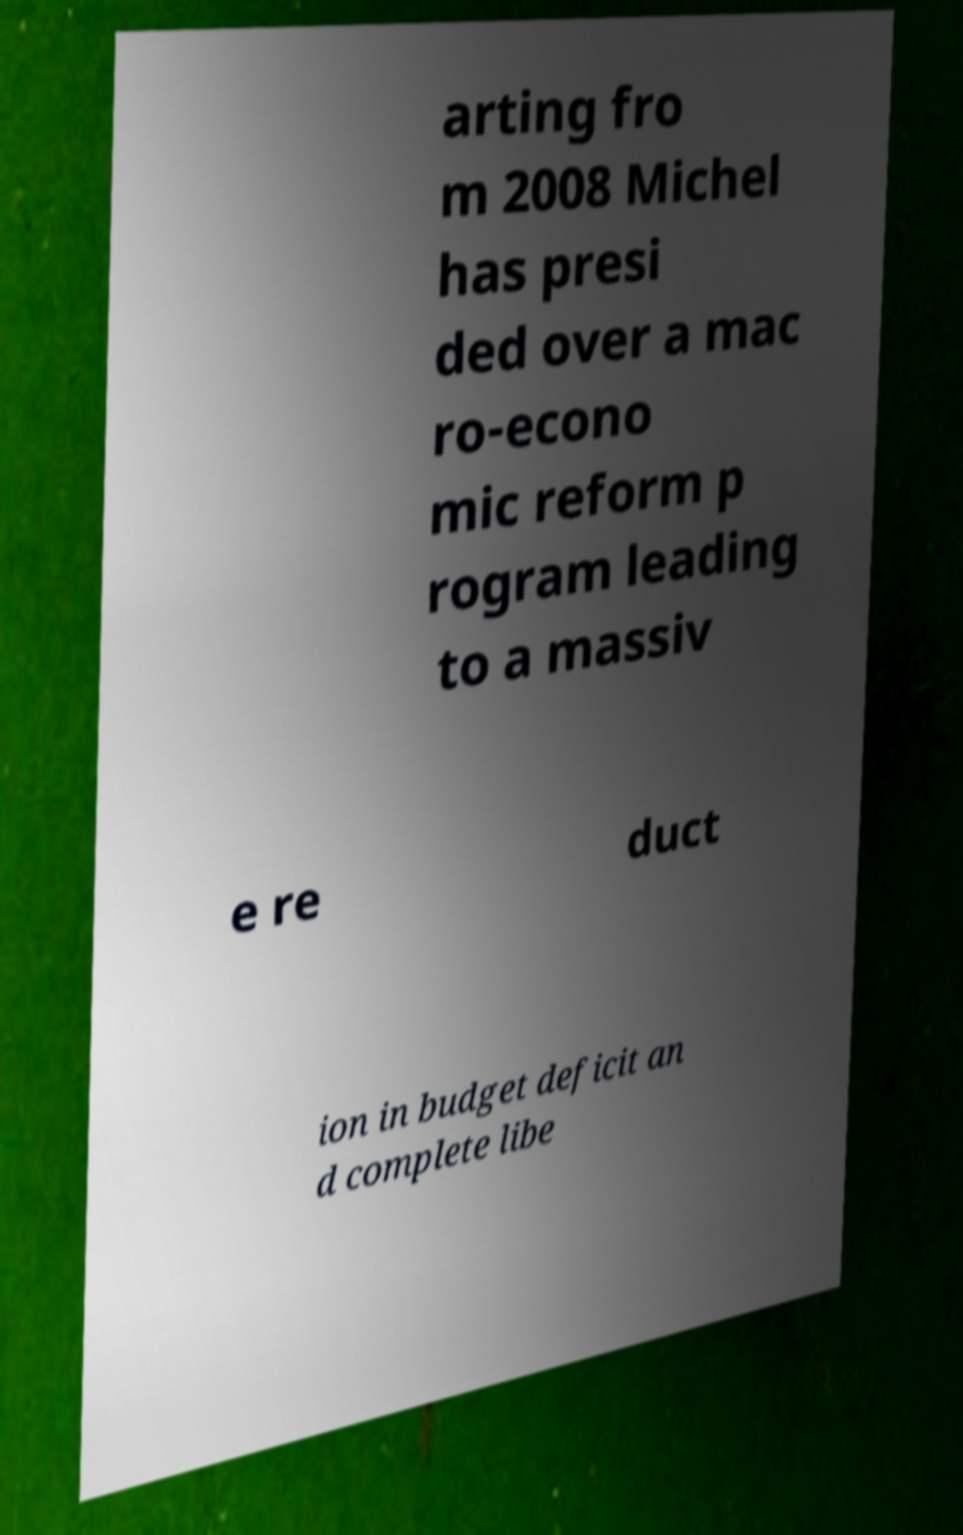There's text embedded in this image that I need extracted. Can you transcribe it verbatim? arting fro m 2008 Michel has presi ded over a mac ro-econo mic reform p rogram leading to a massiv e re duct ion in budget deficit an d complete libe 